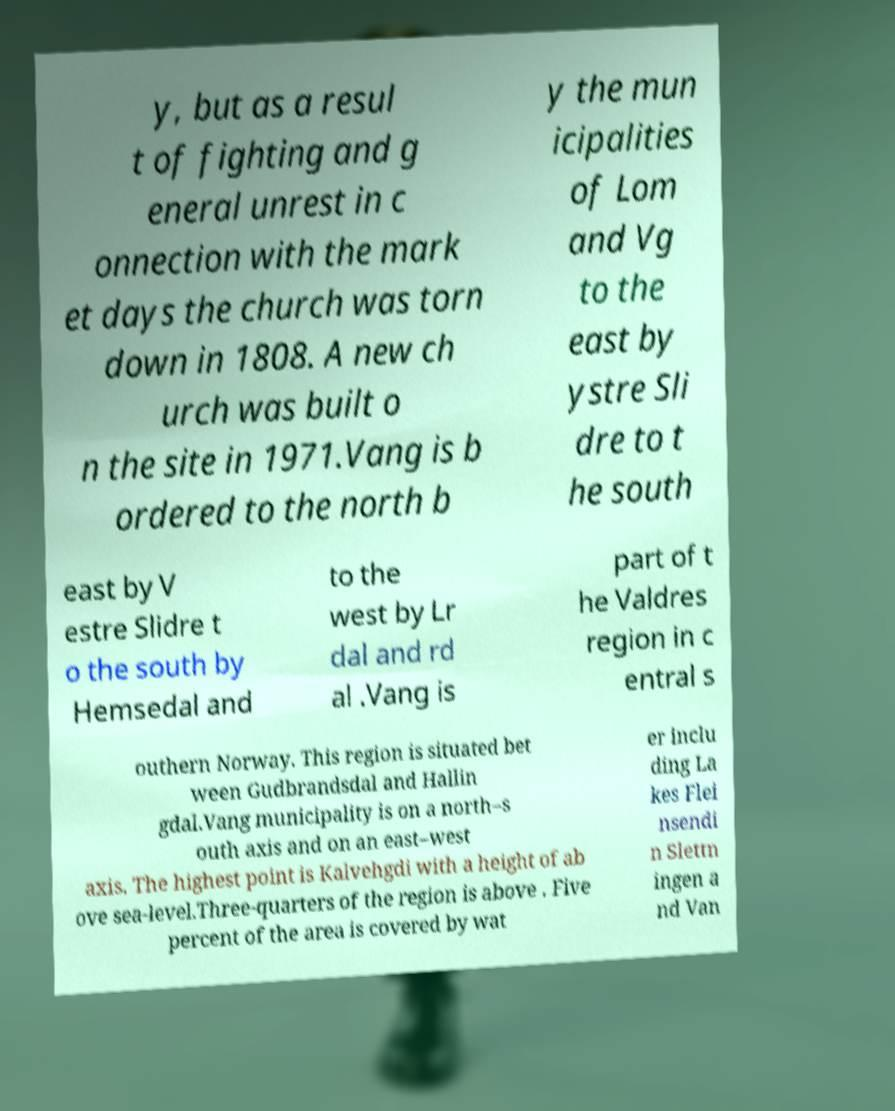For documentation purposes, I need the text within this image transcribed. Could you provide that? y, but as a resul t of fighting and g eneral unrest in c onnection with the mark et days the church was torn down in 1808. A new ch urch was built o n the site in 1971.Vang is b ordered to the north b y the mun icipalities of Lom and Vg to the east by ystre Sli dre to t he south east by V estre Slidre t o the south by Hemsedal and to the west by Lr dal and rd al .Vang is part of t he Valdres region in c entral s outhern Norway. This region is situated bet ween Gudbrandsdal and Hallin gdal.Vang municipality is on a north–s outh axis and on an east–west axis. The highest point is Kalvehgdi with a height of ab ove sea-level.Three-quarters of the region is above . Five percent of the area is covered by wat er inclu ding La kes Flei nsendi n Slettn ingen a nd Van 